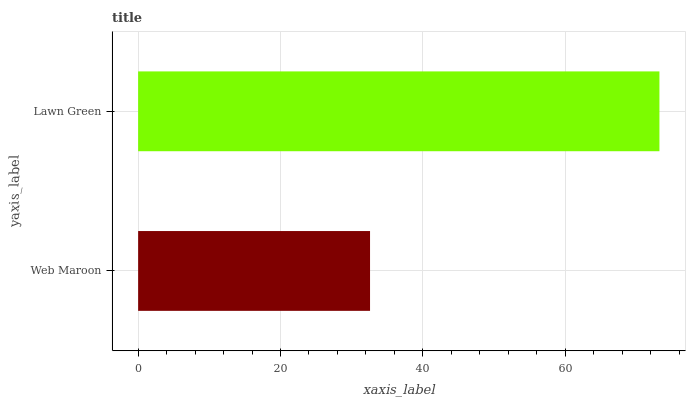Is Web Maroon the minimum?
Answer yes or no. Yes. Is Lawn Green the maximum?
Answer yes or no. Yes. Is Lawn Green the minimum?
Answer yes or no. No. Is Lawn Green greater than Web Maroon?
Answer yes or no. Yes. Is Web Maroon less than Lawn Green?
Answer yes or no. Yes. Is Web Maroon greater than Lawn Green?
Answer yes or no. No. Is Lawn Green less than Web Maroon?
Answer yes or no. No. Is Lawn Green the high median?
Answer yes or no. Yes. Is Web Maroon the low median?
Answer yes or no. Yes. Is Web Maroon the high median?
Answer yes or no. No. Is Lawn Green the low median?
Answer yes or no. No. 